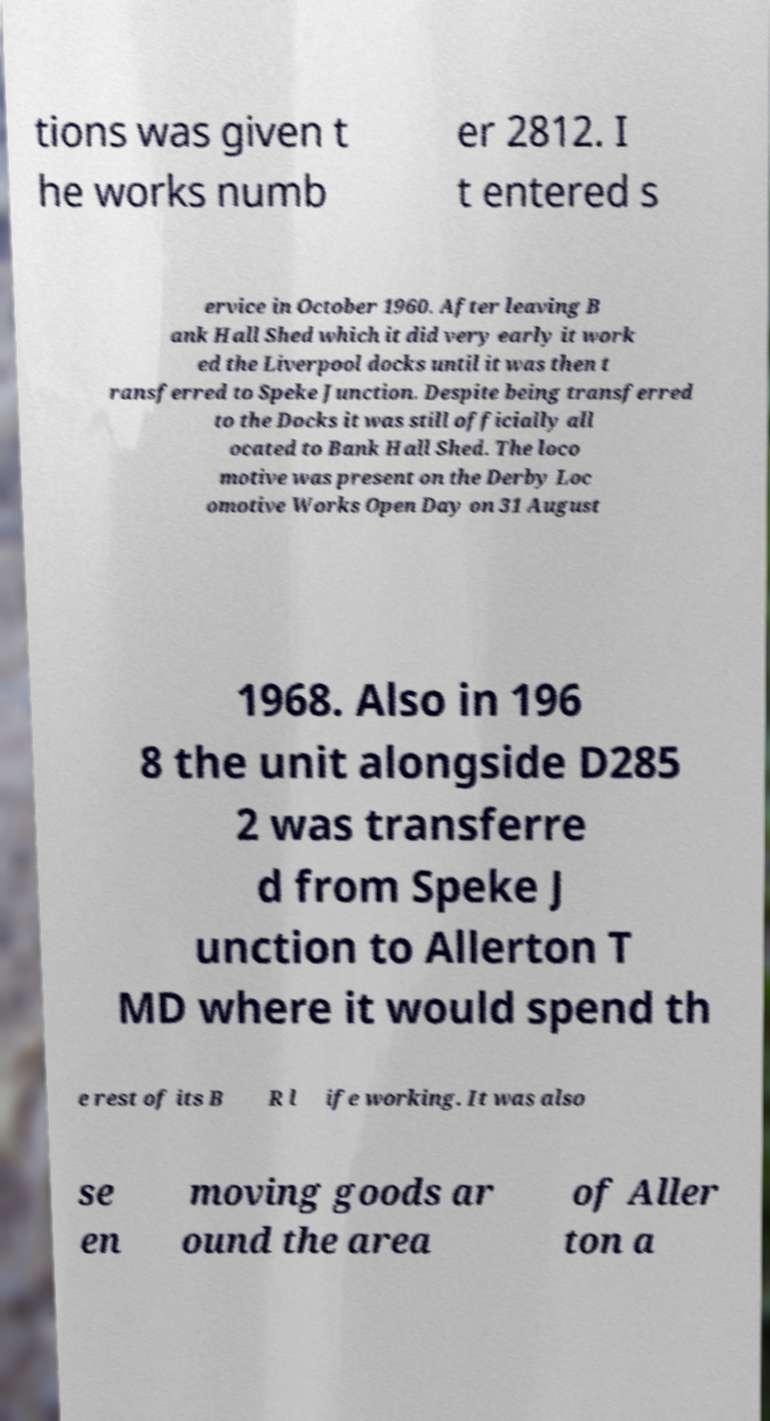I need the written content from this picture converted into text. Can you do that? tions was given t he works numb er 2812. I t entered s ervice in October 1960. After leaving B ank Hall Shed which it did very early it work ed the Liverpool docks until it was then t ransferred to Speke Junction. Despite being transferred to the Docks it was still officially all ocated to Bank Hall Shed. The loco motive was present on the Derby Loc omotive Works Open Day on 31 August 1968. Also in 196 8 the unit alongside D285 2 was transferre d from Speke J unction to Allerton T MD where it would spend th e rest of its B R l ife working. It was also se en moving goods ar ound the area of Aller ton a 